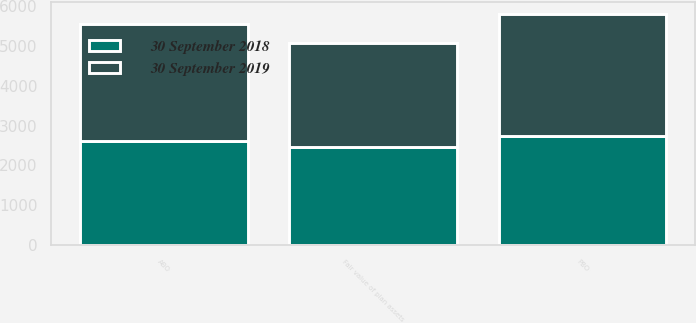<chart> <loc_0><loc_0><loc_500><loc_500><stacked_bar_chart><ecel><fcel>PBO<fcel>Fair value of plan assets<fcel>ABO<nl><fcel>30 September 2019<fcel>3069.2<fcel>2602.8<fcel>2941.2<nl><fcel>30 September 2018<fcel>2733.6<fcel>2467.5<fcel>2608.6<nl></chart> 